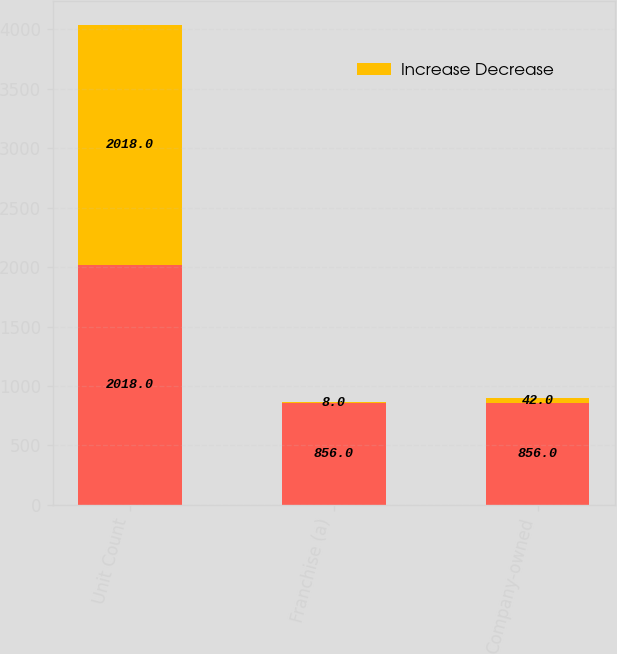Convert chart to OTSL. <chart><loc_0><loc_0><loc_500><loc_500><stacked_bar_chart><ecel><fcel>Unit Count<fcel>Franchise (a)<fcel>Company-owned<nl><fcel>nan<fcel>2018<fcel>856<fcel>856<nl><fcel>Increase Decrease<fcel>2018<fcel>8<fcel>42<nl></chart> 